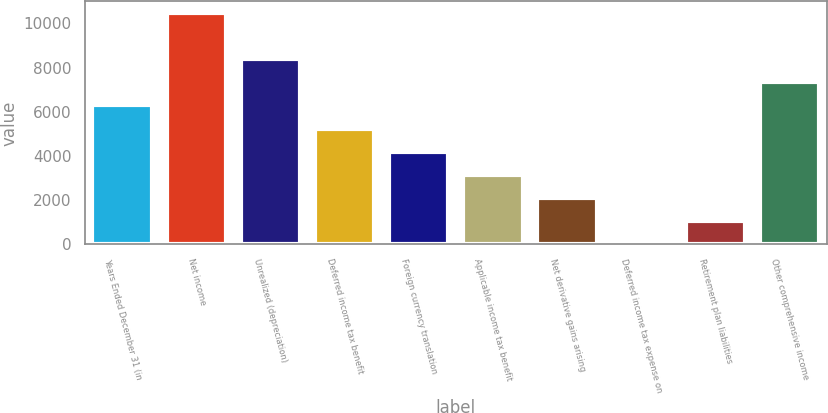<chart> <loc_0><loc_0><loc_500><loc_500><bar_chart><fcel>Years Ended December 31 (in<fcel>Net income<fcel>Unrealized (depreciation)<fcel>Deferred income tax benefit<fcel>Foreign currency translation<fcel>Applicable income tax benefit<fcel>Net derivative gains arising<fcel>Deferred income tax expense on<fcel>Retirement plan liabilities<fcel>Other comprehensive income<nl><fcel>6289<fcel>10477<fcel>8383<fcel>5242<fcel>4195<fcel>3148<fcel>2101<fcel>7<fcel>1054<fcel>7336<nl></chart> 